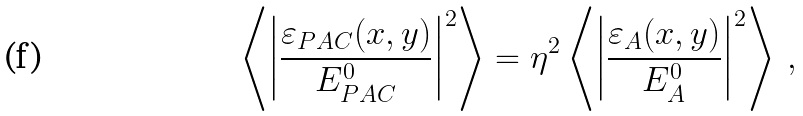<formula> <loc_0><loc_0><loc_500><loc_500>\left \langle \left | \frac { \varepsilon _ { P A C } ( x , y ) } { E _ { P A C } ^ { 0 } } \right | ^ { 2 } \right \rangle = \eta ^ { 2 } \left \langle \left | \frac { \varepsilon _ { A } ( x , y ) } { E _ { A } ^ { 0 } } \right | ^ { 2 } \right \rangle \, ,</formula> 